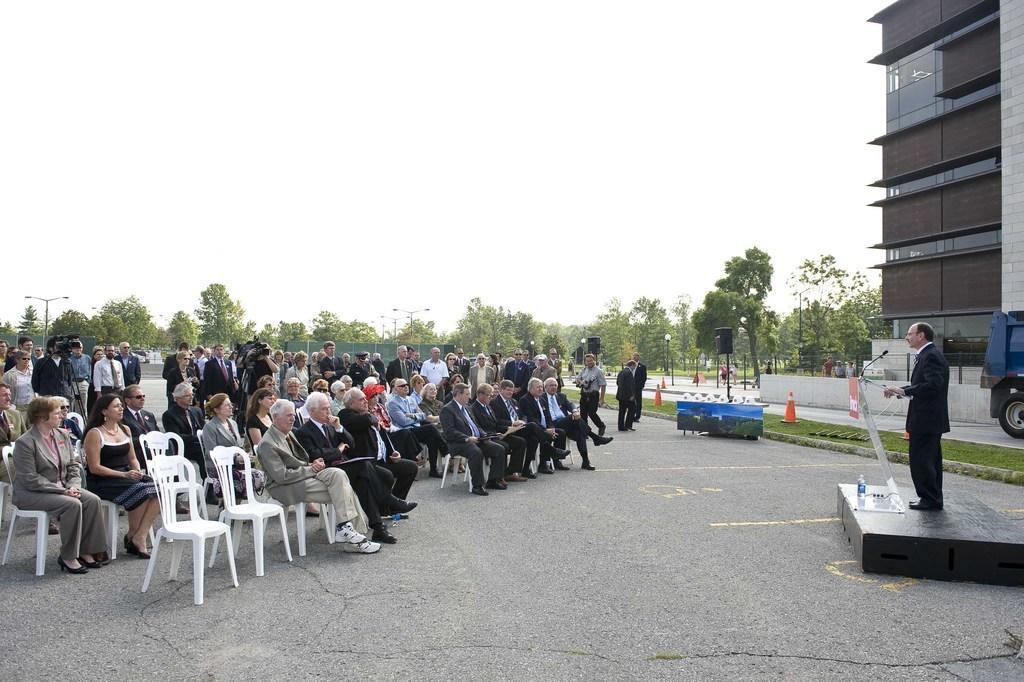Please provide a concise description of this image. there are so many people sitting and standing on a road behind them is other man standing on the stage and speaking on the microphone and there is a building beside along with some trees. 